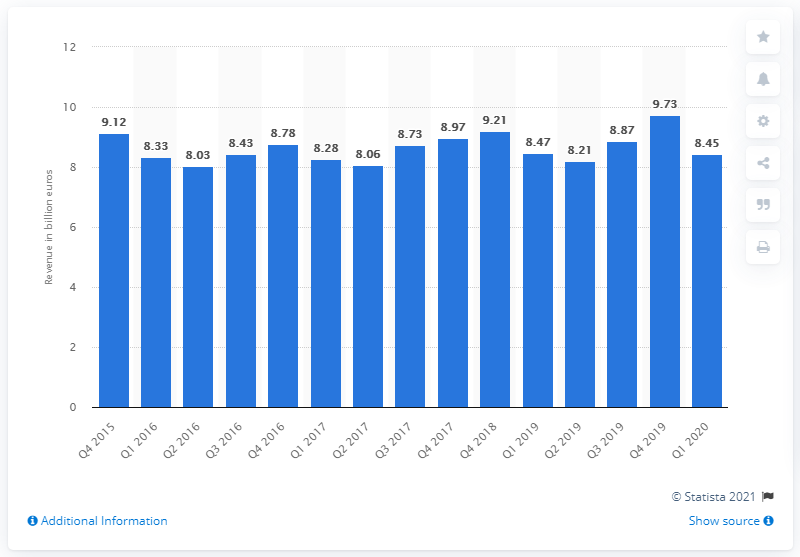Highlight a few significant elements in this photo. In the first quarter of 2020, the revenue of MDA was $8.45 million. The revenue from MDA in the fourth quarter of 2015 was 9.21. 